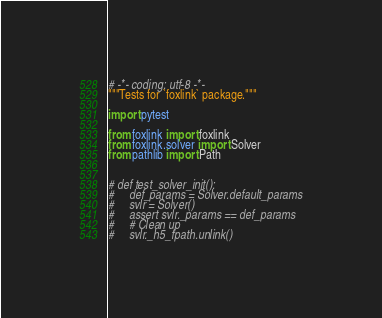<code> <loc_0><loc_0><loc_500><loc_500><_Python_># -*- coding: utf-8 -*-
"""Tests for `foxlink` package."""

import pytest

from foxlink import foxlink
from foxlink.solver import Solver
from pathlib import Path


# def test_solver_init():
#     def_params = Solver.default_params
#     svlr = Solver()
#     assert svlr._params == def_params
#     # Clean up
#     svlr._h5_fpath.unlink()
</code> 